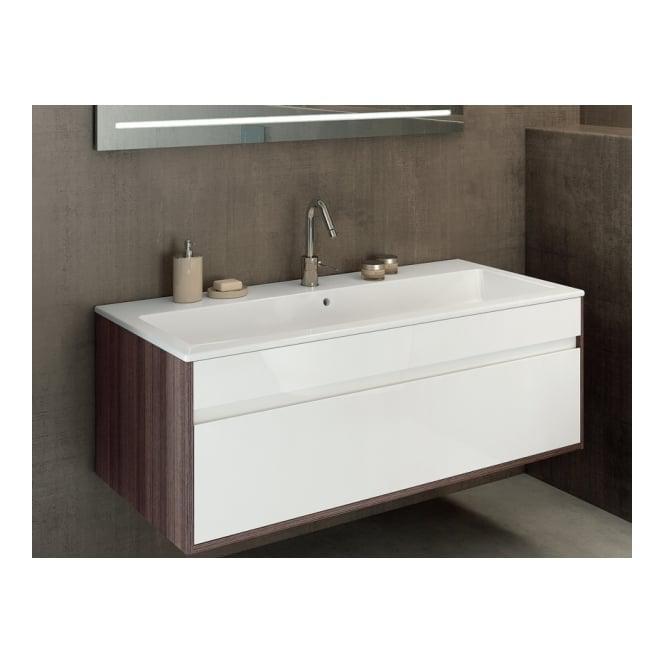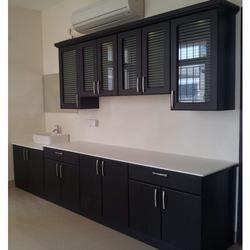The first image is the image on the left, the second image is the image on the right. For the images shown, is this caption "Atleast one picture has black cabinets." true? Answer yes or no. Yes. The first image is the image on the left, the second image is the image on the right. For the images shown, is this caption "The right image shows glass-fronted black cabinets mounted on the wall above a counter with black cabinets that sits on the floor." true? Answer yes or no. Yes. 